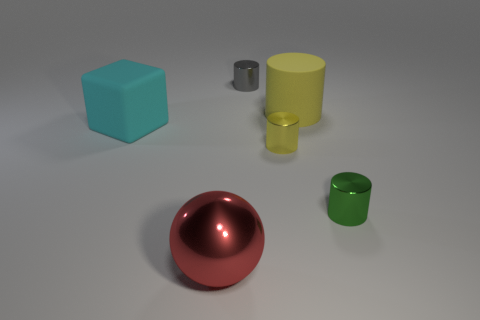Subtract all gray cylinders. How many cylinders are left? 3 Subtract all blue cylinders. Subtract all cyan blocks. How many cylinders are left? 4 Add 2 big green metal cylinders. How many objects exist? 8 Subtract all cubes. How many objects are left? 5 Subtract 1 gray cylinders. How many objects are left? 5 Subtract all big red matte balls. Subtract all red spheres. How many objects are left? 5 Add 2 gray cylinders. How many gray cylinders are left? 3 Add 1 tiny gray cubes. How many tiny gray cubes exist? 1 